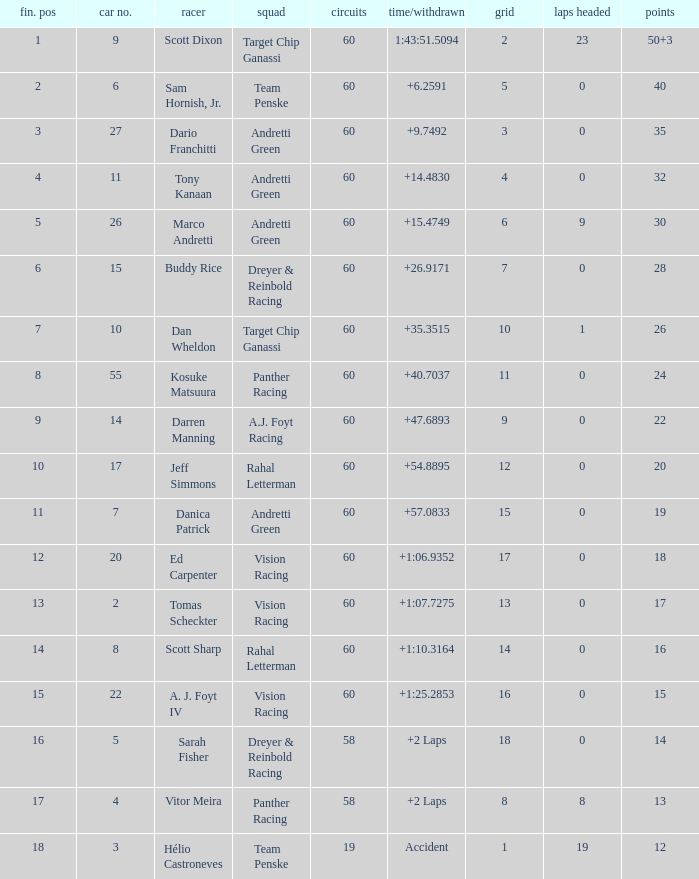Name the total number of grid for 30 1.0. 